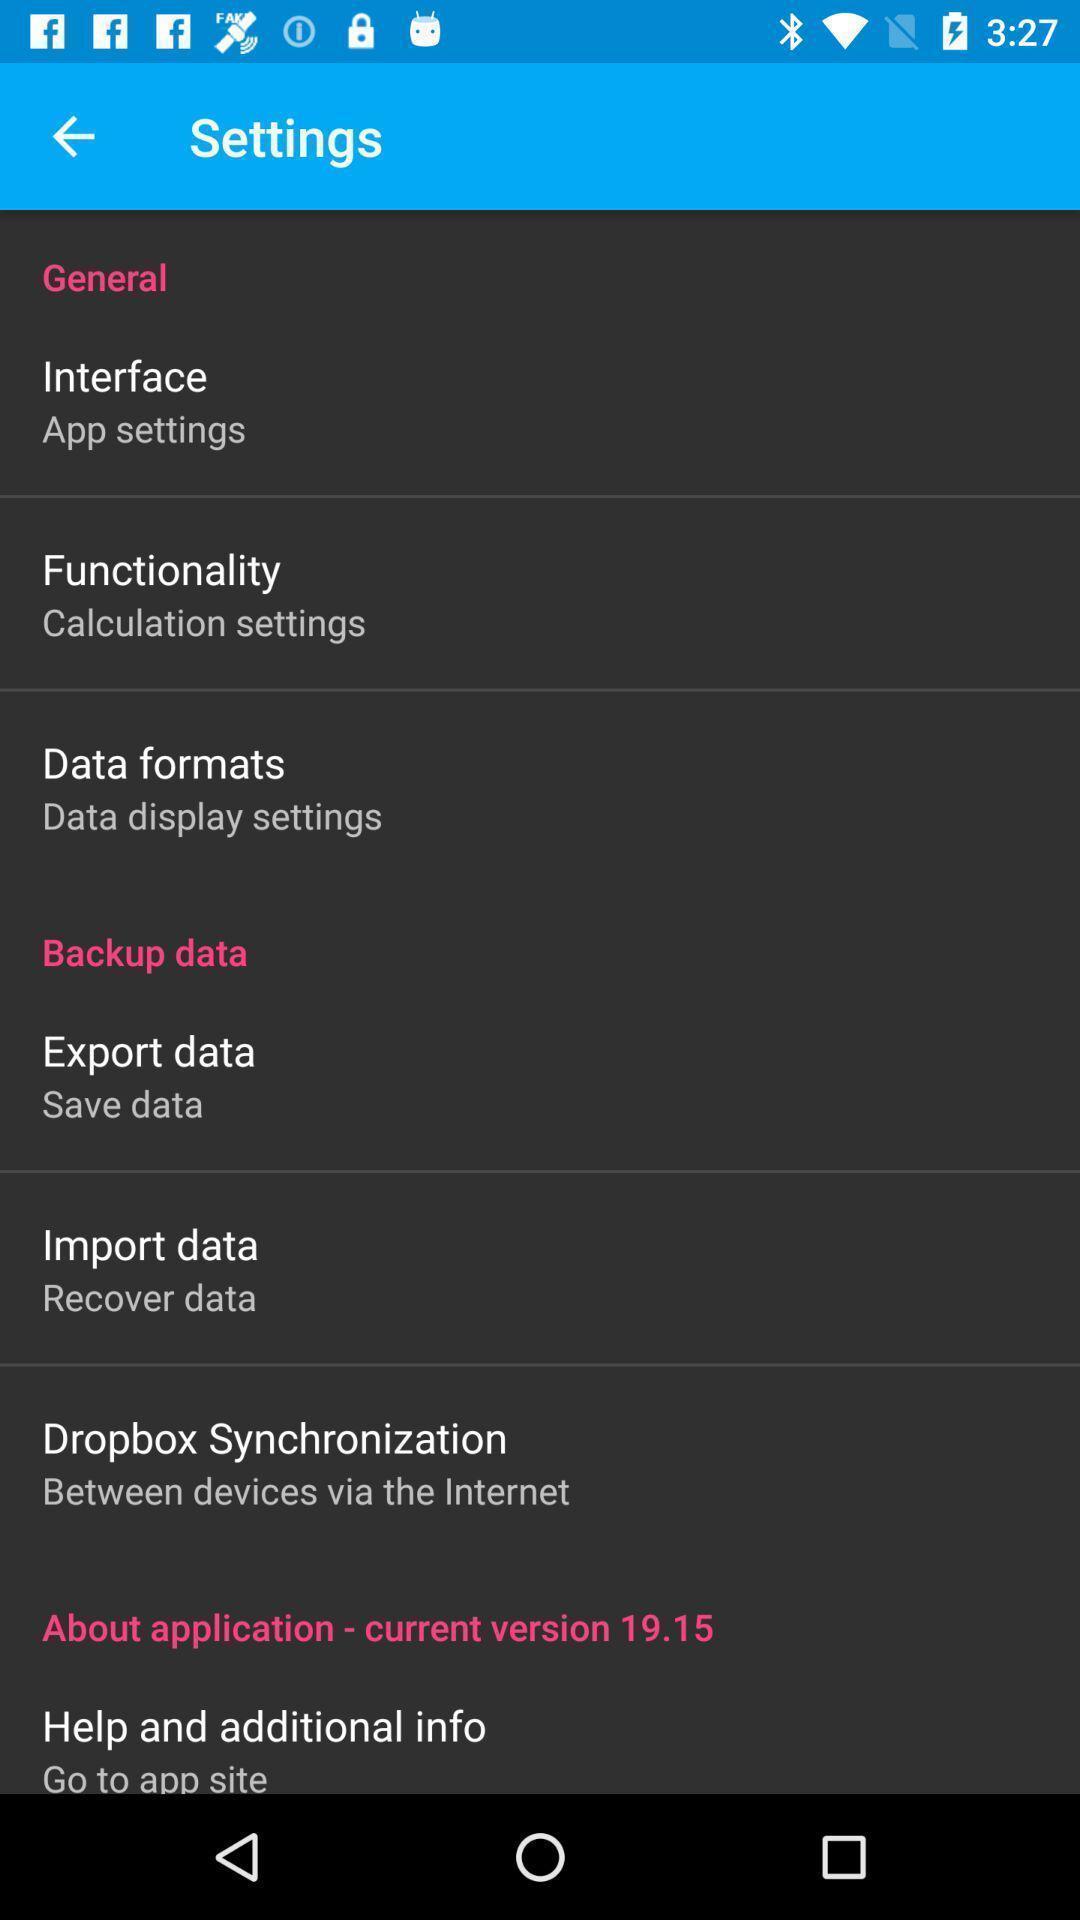Tell me about the visual elements in this screen capture. Settings page. 